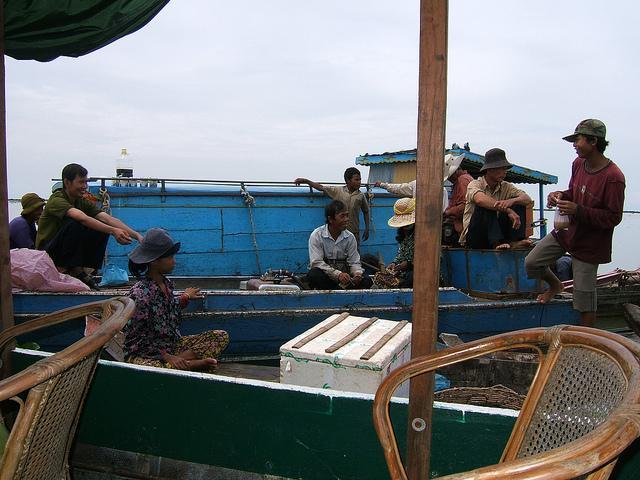How many people wearing hats?
Give a very brief answer. 6. How many boats are in the photo?
Give a very brief answer. 3. How many chairs are in the picture?
Give a very brief answer. 2. How many people can be seen?
Give a very brief answer. 5. 